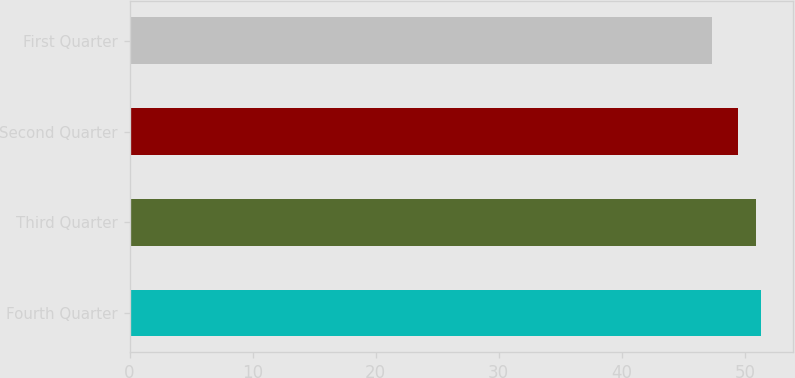Convert chart. <chart><loc_0><loc_0><loc_500><loc_500><bar_chart><fcel>Fourth Quarter<fcel>Third Quarter<fcel>Second Quarter<fcel>First Quarter<nl><fcel>51.35<fcel>50.94<fcel>49.43<fcel>47.33<nl></chart> 